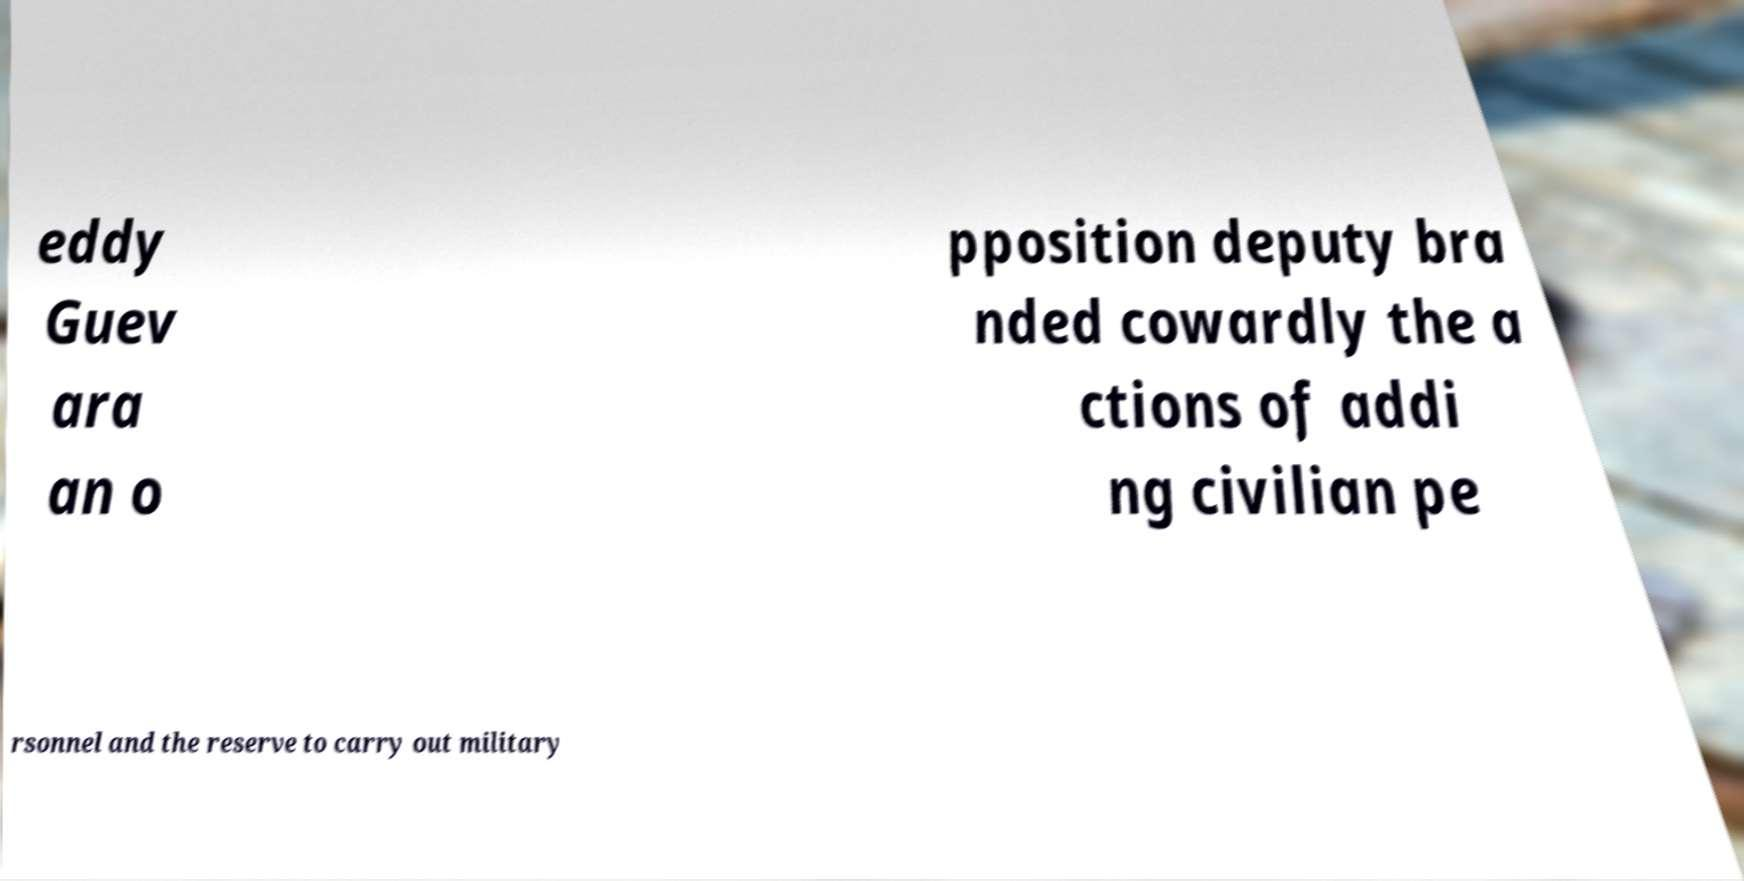Can you accurately transcribe the text from the provided image for me? eddy Guev ara an o pposition deputy bra nded cowardly the a ctions of addi ng civilian pe rsonnel and the reserve to carry out military 